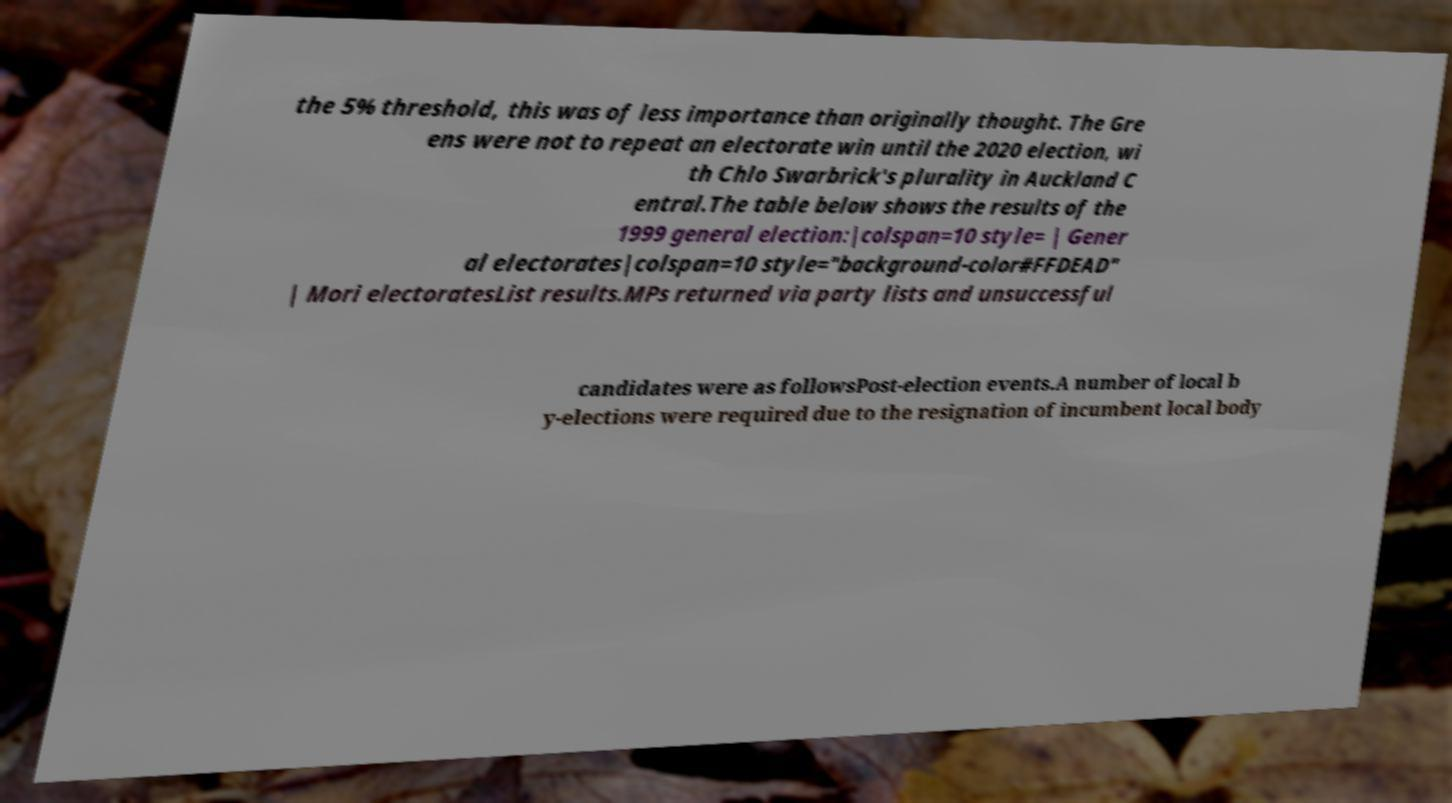Could you assist in decoding the text presented in this image and type it out clearly? the 5% threshold, this was of less importance than originally thought. The Gre ens were not to repeat an electorate win until the 2020 election, wi th Chlo Swarbrick's plurality in Auckland C entral.The table below shows the results of the 1999 general election:|colspan=10 style= | Gener al electorates|colspan=10 style="background-color#FFDEAD" | Mori electoratesList results.MPs returned via party lists and unsuccessful candidates were as followsPost-election events.A number of local b y-elections were required due to the resignation of incumbent local body 